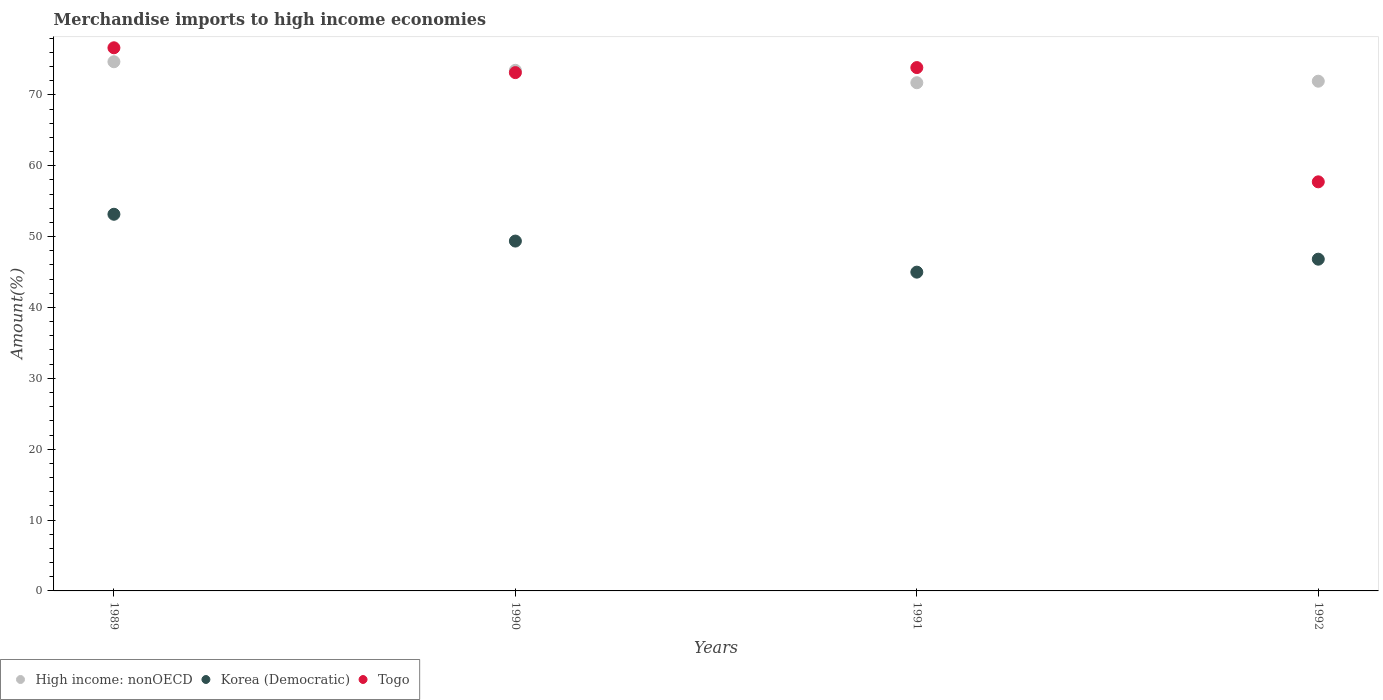How many different coloured dotlines are there?
Provide a succinct answer. 3. Is the number of dotlines equal to the number of legend labels?
Provide a short and direct response. Yes. What is the percentage of amount earned from merchandise imports in Korea (Democratic) in 1991?
Give a very brief answer. 44.99. Across all years, what is the maximum percentage of amount earned from merchandise imports in Korea (Democratic)?
Give a very brief answer. 53.15. Across all years, what is the minimum percentage of amount earned from merchandise imports in Korea (Democratic)?
Provide a short and direct response. 44.99. In which year was the percentage of amount earned from merchandise imports in Korea (Democratic) minimum?
Make the answer very short. 1991. What is the total percentage of amount earned from merchandise imports in Korea (Democratic) in the graph?
Provide a short and direct response. 194.33. What is the difference between the percentage of amount earned from merchandise imports in Korea (Democratic) in 1990 and that in 1991?
Offer a very short reply. 4.39. What is the difference between the percentage of amount earned from merchandise imports in Togo in 1989 and the percentage of amount earned from merchandise imports in Korea (Democratic) in 1990?
Keep it short and to the point. 27.28. What is the average percentage of amount earned from merchandise imports in Togo per year?
Your answer should be compact. 70.34. In the year 1990, what is the difference between the percentage of amount earned from merchandise imports in Korea (Democratic) and percentage of amount earned from merchandise imports in High income: nonOECD?
Your answer should be very brief. -24.1. What is the ratio of the percentage of amount earned from merchandise imports in Togo in 1990 to that in 1992?
Provide a succinct answer. 1.27. What is the difference between the highest and the second highest percentage of amount earned from merchandise imports in High income: nonOECD?
Offer a very short reply. 1.21. What is the difference between the highest and the lowest percentage of amount earned from merchandise imports in Togo?
Provide a succinct answer. 18.92. Is the sum of the percentage of amount earned from merchandise imports in Korea (Democratic) in 1991 and 1992 greater than the maximum percentage of amount earned from merchandise imports in High income: nonOECD across all years?
Keep it short and to the point. Yes. Is it the case that in every year, the sum of the percentage of amount earned from merchandise imports in Korea (Democratic) and percentage of amount earned from merchandise imports in High income: nonOECD  is greater than the percentage of amount earned from merchandise imports in Togo?
Make the answer very short. Yes. Does the percentage of amount earned from merchandise imports in Togo monotonically increase over the years?
Ensure brevity in your answer.  No. Is the percentage of amount earned from merchandise imports in Togo strictly greater than the percentage of amount earned from merchandise imports in High income: nonOECD over the years?
Keep it short and to the point. No. Are the values on the major ticks of Y-axis written in scientific E-notation?
Keep it short and to the point. No. Does the graph contain any zero values?
Give a very brief answer. No. Does the graph contain grids?
Your response must be concise. No. Where does the legend appear in the graph?
Give a very brief answer. Bottom left. What is the title of the graph?
Give a very brief answer. Merchandise imports to high income economies. What is the label or title of the X-axis?
Your response must be concise. Years. What is the label or title of the Y-axis?
Your response must be concise. Amount(%). What is the Amount(%) in High income: nonOECD in 1989?
Make the answer very short. 74.68. What is the Amount(%) in Korea (Democratic) in 1989?
Give a very brief answer. 53.15. What is the Amount(%) in Togo in 1989?
Provide a short and direct response. 76.65. What is the Amount(%) in High income: nonOECD in 1990?
Provide a short and direct response. 73.47. What is the Amount(%) of Korea (Democratic) in 1990?
Your answer should be very brief. 49.37. What is the Amount(%) of Togo in 1990?
Give a very brief answer. 73.14. What is the Amount(%) in High income: nonOECD in 1991?
Your answer should be very brief. 71.72. What is the Amount(%) in Korea (Democratic) in 1991?
Offer a terse response. 44.99. What is the Amount(%) in Togo in 1991?
Provide a succinct answer. 73.85. What is the Amount(%) in High income: nonOECD in 1992?
Your answer should be compact. 71.93. What is the Amount(%) of Korea (Democratic) in 1992?
Make the answer very short. 46.81. What is the Amount(%) in Togo in 1992?
Offer a very short reply. 57.73. Across all years, what is the maximum Amount(%) of High income: nonOECD?
Give a very brief answer. 74.68. Across all years, what is the maximum Amount(%) in Korea (Democratic)?
Offer a terse response. 53.15. Across all years, what is the maximum Amount(%) in Togo?
Your response must be concise. 76.65. Across all years, what is the minimum Amount(%) of High income: nonOECD?
Offer a very short reply. 71.72. Across all years, what is the minimum Amount(%) of Korea (Democratic)?
Offer a terse response. 44.99. Across all years, what is the minimum Amount(%) of Togo?
Ensure brevity in your answer.  57.73. What is the total Amount(%) in High income: nonOECD in the graph?
Give a very brief answer. 291.8. What is the total Amount(%) of Korea (Democratic) in the graph?
Provide a short and direct response. 194.33. What is the total Amount(%) in Togo in the graph?
Make the answer very short. 281.38. What is the difference between the Amount(%) in High income: nonOECD in 1989 and that in 1990?
Your response must be concise. 1.21. What is the difference between the Amount(%) of Korea (Democratic) in 1989 and that in 1990?
Your answer should be compact. 3.78. What is the difference between the Amount(%) of Togo in 1989 and that in 1990?
Provide a short and direct response. 3.5. What is the difference between the Amount(%) of High income: nonOECD in 1989 and that in 1991?
Provide a short and direct response. 2.96. What is the difference between the Amount(%) of Korea (Democratic) in 1989 and that in 1991?
Your answer should be very brief. 8.17. What is the difference between the Amount(%) of Togo in 1989 and that in 1991?
Make the answer very short. 2.79. What is the difference between the Amount(%) of High income: nonOECD in 1989 and that in 1992?
Make the answer very short. 2.75. What is the difference between the Amount(%) of Korea (Democratic) in 1989 and that in 1992?
Ensure brevity in your answer.  6.34. What is the difference between the Amount(%) in Togo in 1989 and that in 1992?
Keep it short and to the point. 18.92. What is the difference between the Amount(%) in High income: nonOECD in 1990 and that in 1991?
Make the answer very short. 1.75. What is the difference between the Amount(%) in Korea (Democratic) in 1990 and that in 1991?
Provide a short and direct response. 4.39. What is the difference between the Amount(%) of Togo in 1990 and that in 1991?
Your response must be concise. -0.71. What is the difference between the Amount(%) in High income: nonOECD in 1990 and that in 1992?
Keep it short and to the point. 1.54. What is the difference between the Amount(%) in Korea (Democratic) in 1990 and that in 1992?
Offer a very short reply. 2.56. What is the difference between the Amount(%) in Togo in 1990 and that in 1992?
Make the answer very short. 15.41. What is the difference between the Amount(%) of High income: nonOECD in 1991 and that in 1992?
Ensure brevity in your answer.  -0.22. What is the difference between the Amount(%) of Korea (Democratic) in 1991 and that in 1992?
Your answer should be compact. -1.83. What is the difference between the Amount(%) of Togo in 1991 and that in 1992?
Ensure brevity in your answer.  16.12. What is the difference between the Amount(%) of High income: nonOECD in 1989 and the Amount(%) of Korea (Democratic) in 1990?
Your response must be concise. 25.31. What is the difference between the Amount(%) of High income: nonOECD in 1989 and the Amount(%) of Togo in 1990?
Make the answer very short. 1.53. What is the difference between the Amount(%) in Korea (Democratic) in 1989 and the Amount(%) in Togo in 1990?
Your answer should be compact. -19.99. What is the difference between the Amount(%) in High income: nonOECD in 1989 and the Amount(%) in Korea (Democratic) in 1991?
Your response must be concise. 29.69. What is the difference between the Amount(%) in High income: nonOECD in 1989 and the Amount(%) in Togo in 1991?
Your answer should be very brief. 0.82. What is the difference between the Amount(%) in Korea (Democratic) in 1989 and the Amount(%) in Togo in 1991?
Provide a short and direct response. -20.7. What is the difference between the Amount(%) of High income: nonOECD in 1989 and the Amount(%) of Korea (Democratic) in 1992?
Provide a short and direct response. 27.86. What is the difference between the Amount(%) in High income: nonOECD in 1989 and the Amount(%) in Togo in 1992?
Give a very brief answer. 16.95. What is the difference between the Amount(%) in Korea (Democratic) in 1989 and the Amount(%) in Togo in 1992?
Your answer should be very brief. -4.58. What is the difference between the Amount(%) in High income: nonOECD in 1990 and the Amount(%) in Korea (Democratic) in 1991?
Your answer should be compact. 28.48. What is the difference between the Amount(%) in High income: nonOECD in 1990 and the Amount(%) in Togo in 1991?
Provide a succinct answer. -0.39. What is the difference between the Amount(%) of Korea (Democratic) in 1990 and the Amount(%) of Togo in 1991?
Offer a very short reply. -24.48. What is the difference between the Amount(%) of High income: nonOECD in 1990 and the Amount(%) of Korea (Democratic) in 1992?
Provide a succinct answer. 26.65. What is the difference between the Amount(%) in High income: nonOECD in 1990 and the Amount(%) in Togo in 1992?
Make the answer very short. 15.74. What is the difference between the Amount(%) of Korea (Democratic) in 1990 and the Amount(%) of Togo in 1992?
Your answer should be compact. -8.36. What is the difference between the Amount(%) of High income: nonOECD in 1991 and the Amount(%) of Korea (Democratic) in 1992?
Make the answer very short. 24.9. What is the difference between the Amount(%) of High income: nonOECD in 1991 and the Amount(%) of Togo in 1992?
Make the answer very short. 13.98. What is the difference between the Amount(%) of Korea (Democratic) in 1991 and the Amount(%) of Togo in 1992?
Your response must be concise. -12.75. What is the average Amount(%) of High income: nonOECD per year?
Provide a short and direct response. 72.95. What is the average Amount(%) of Korea (Democratic) per year?
Keep it short and to the point. 48.58. What is the average Amount(%) in Togo per year?
Provide a short and direct response. 70.34. In the year 1989, what is the difference between the Amount(%) of High income: nonOECD and Amount(%) of Korea (Democratic)?
Ensure brevity in your answer.  21.52. In the year 1989, what is the difference between the Amount(%) of High income: nonOECD and Amount(%) of Togo?
Offer a terse response. -1.97. In the year 1989, what is the difference between the Amount(%) in Korea (Democratic) and Amount(%) in Togo?
Provide a succinct answer. -23.49. In the year 1990, what is the difference between the Amount(%) in High income: nonOECD and Amount(%) in Korea (Democratic)?
Your answer should be very brief. 24.1. In the year 1990, what is the difference between the Amount(%) of High income: nonOECD and Amount(%) of Togo?
Provide a short and direct response. 0.32. In the year 1990, what is the difference between the Amount(%) of Korea (Democratic) and Amount(%) of Togo?
Offer a very short reply. -23.77. In the year 1991, what is the difference between the Amount(%) in High income: nonOECD and Amount(%) in Korea (Democratic)?
Ensure brevity in your answer.  26.73. In the year 1991, what is the difference between the Amount(%) in High income: nonOECD and Amount(%) in Togo?
Give a very brief answer. -2.14. In the year 1991, what is the difference between the Amount(%) in Korea (Democratic) and Amount(%) in Togo?
Your answer should be very brief. -28.87. In the year 1992, what is the difference between the Amount(%) in High income: nonOECD and Amount(%) in Korea (Democratic)?
Offer a very short reply. 25.12. In the year 1992, what is the difference between the Amount(%) of High income: nonOECD and Amount(%) of Togo?
Your answer should be compact. 14.2. In the year 1992, what is the difference between the Amount(%) in Korea (Democratic) and Amount(%) in Togo?
Make the answer very short. -10.92. What is the ratio of the Amount(%) of High income: nonOECD in 1989 to that in 1990?
Give a very brief answer. 1.02. What is the ratio of the Amount(%) in Korea (Democratic) in 1989 to that in 1990?
Your response must be concise. 1.08. What is the ratio of the Amount(%) in Togo in 1989 to that in 1990?
Your answer should be very brief. 1.05. What is the ratio of the Amount(%) in High income: nonOECD in 1989 to that in 1991?
Offer a terse response. 1.04. What is the ratio of the Amount(%) of Korea (Democratic) in 1989 to that in 1991?
Offer a very short reply. 1.18. What is the ratio of the Amount(%) of Togo in 1989 to that in 1991?
Your answer should be compact. 1.04. What is the ratio of the Amount(%) in High income: nonOECD in 1989 to that in 1992?
Your answer should be very brief. 1.04. What is the ratio of the Amount(%) of Korea (Democratic) in 1989 to that in 1992?
Ensure brevity in your answer.  1.14. What is the ratio of the Amount(%) in Togo in 1989 to that in 1992?
Ensure brevity in your answer.  1.33. What is the ratio of the Amount(%) of High income: nonOECD in 1990 to that in 1991?
Your answer should be very brief. 1.02. What is the ratio of the Amount(%) of Korea (Democratic) in 1990 to that in 1991?
Offer a terse response. 1.1. What is the ratio of the Amount(%) in High income: nonOECD in 1990 to that in 1992?
Your response must be concise. 1.02. What is the ratio of the Amount(%) in Korea (Democratic) in 1990 to that in 1992?
Ensure brevity in your answer.  1.05. What is the ratio of the Amount(%) in Togo in 1990 to that in 1992?
Ensure brevity in your answer.  1.27. What is the ratio of the Amount(%) in Korea (Democratic) in 1991 to that in 1992?
Give a very brief answer. 0.96. What is the ratio of the Amount(%) of Togo in 1991 to that in 1992?
Give a very brief answer. 1.28. What is the difference between the highest and the second highest Amount(%) in High income: nonOECD?
Provide a short and direct response. 1.21. What is the difference between the highest and the second highest Amount(%) of Korea (Democratic)?
Provide a succinct answer. 3.78. What is the difference between the highest and the second highest Amount(%) in Togo?
Make the answer very short. 2.79. What is the difference between the highest and the lowest Amount(%) of High income: nonOECD?
Make the answer very short. 2.96. What is the difference between the highest and the lowest Amount(%) in Korea (Democratic)?
Ensure brevity in your answer.  8.17. What is the difference between the highest and the lowest Amount(%) of Togo?
Your answer should be compact. 18.92. 